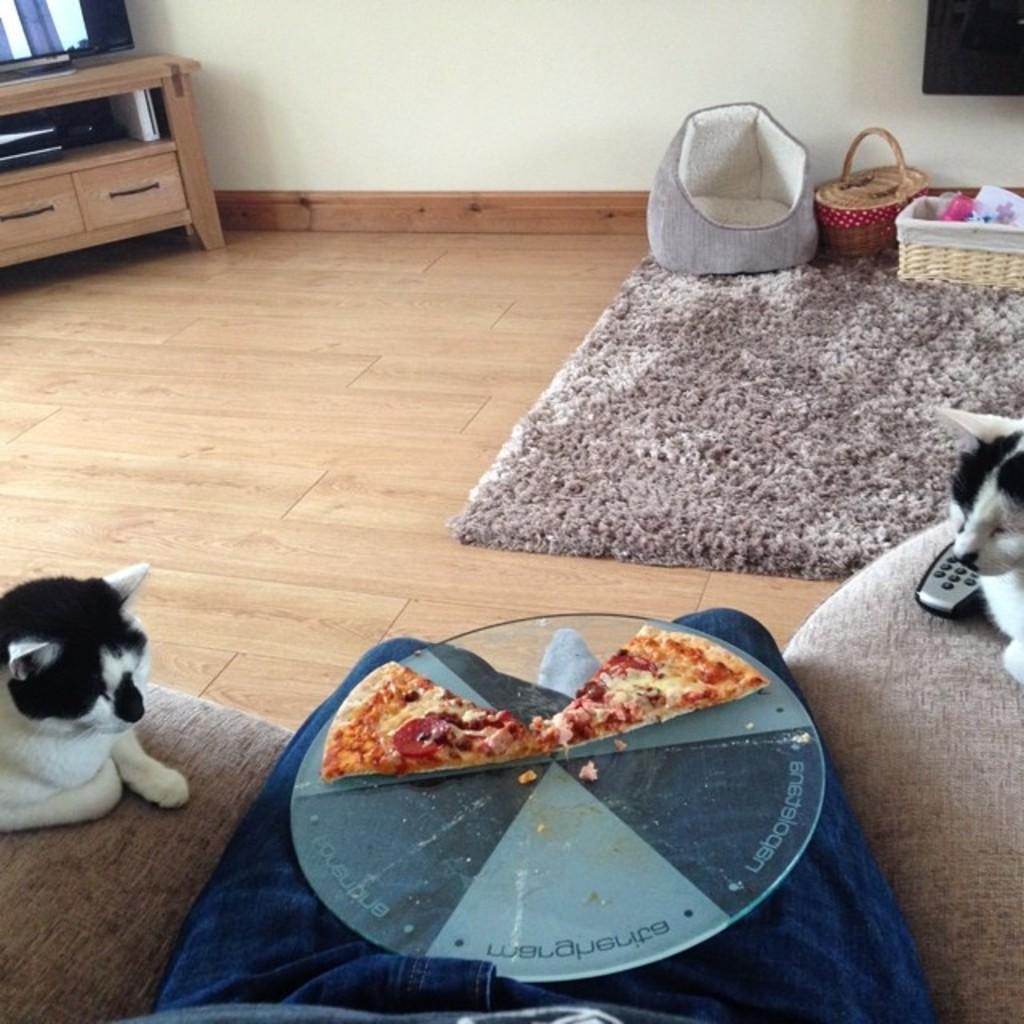In one or two sentences, can you explain what this image depicts? this picture shows two Pizza slices on a tray on the on the person's lap and we see two cats watching it on the couch and we see a chair and two baskets and a carpet and we see a table and on the table we see a television 